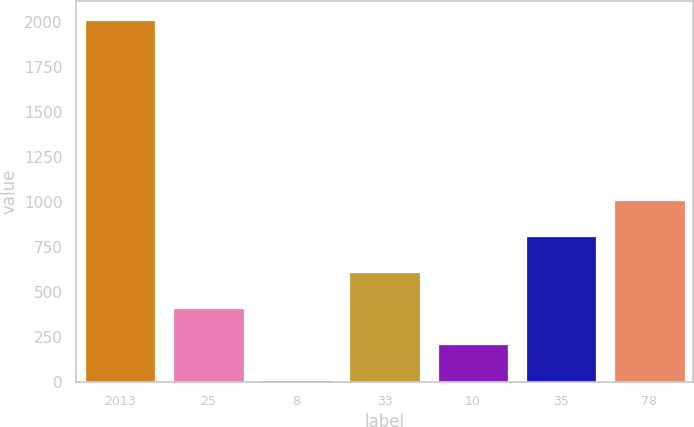Convert chart to OTSL. <chart><loc_0><loc_0><loc_500><loc_500><bar_chart><fcel>2013<fcel>25<fcel>8<fcel>33<fcel>10<fcel>35<fcel>78<nl><fcel>2011<fcel>407.8<fcel>7<fcel>608.2<fcel>207.4<fcel>808.6<fcel>1009<nl></chart> 